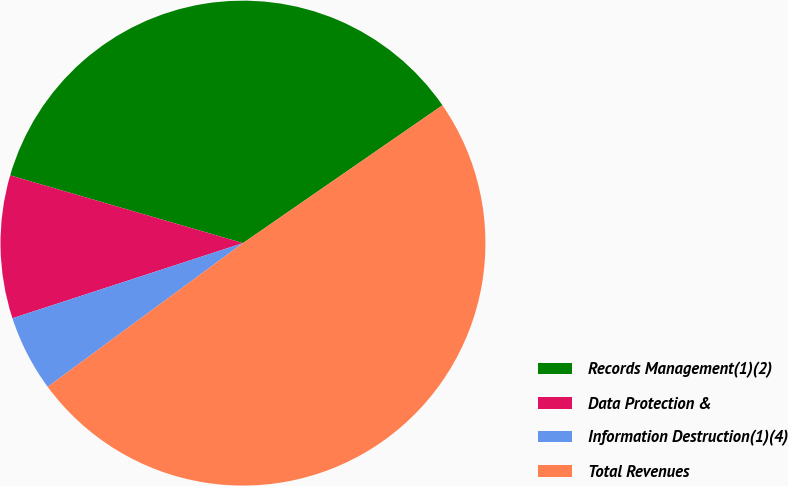Convert chart. <chart><loc_0><loc_0><loc_500><loc_500><pie_chart><fcel>Records Management(1)(2)<fcel>Data Protection &<fcel>Information Destruction(1)(4)<fcel>Total Revenues<nl><fcel>35.87%<fcel>9.52%<fcel>5.08%<fcel>49.53%<nl></chart> 